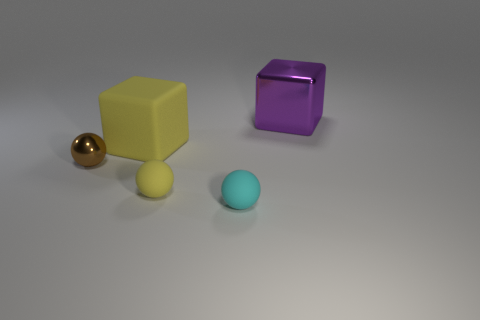What can you tell me about the lighting in this scene? The lighting in this image appears to be coming from the top-left corner, casting a soft shadow on the right side of the objects. It's a diffused light which creates gentle shadows and gives the scene a calm ambience. 